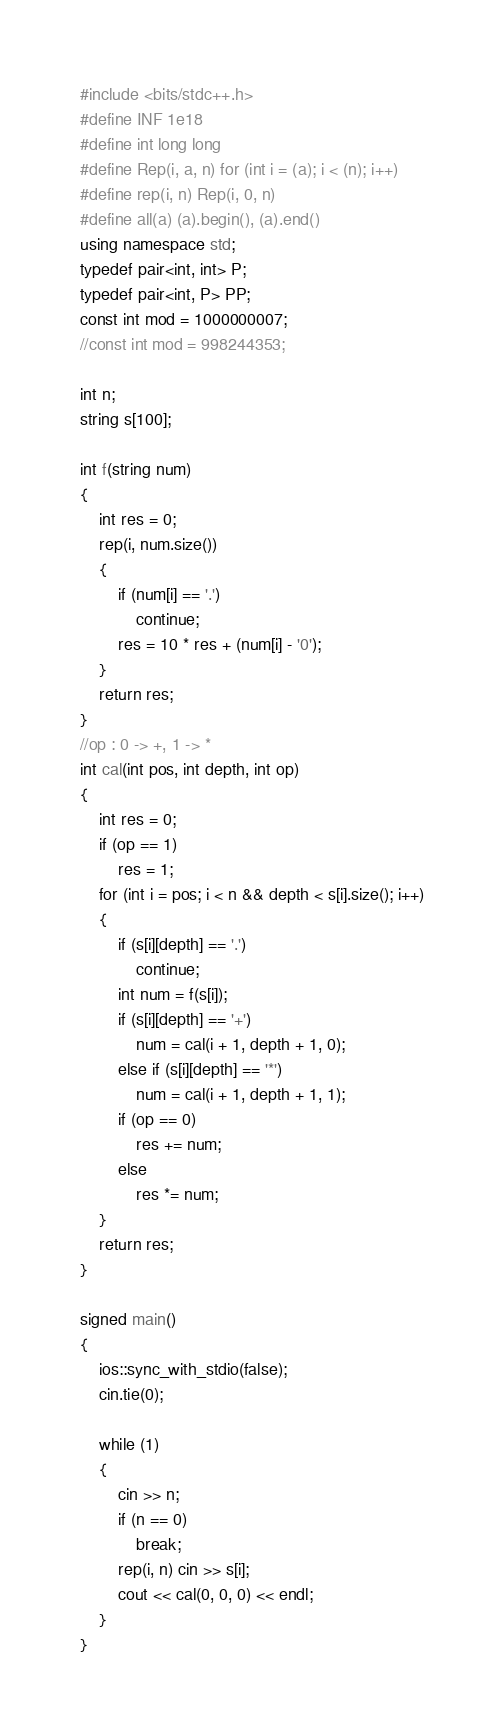Convert code to text. <code><loc_0><loc_0><loc_500><loc_500><_C++_>#include <bits/stdc++.h>
#define INF 1e18
#define int long long
#define Rep(i, a, n) for (int i = (a); i < (n); i++)
#define rep(i, n) Rep(i, 0, n)
#define all(a) (a).begin(), (a).end()
using namespace std;
typedef pair<int, int> P;
typedef pair<int, P> PP;
const int mod = 1000000007;
//const int mod = 998244353;

int n;
string s[100];

int f(string num)
{
    int res = 0;
    rep(i, num.size())
    {
        if (num[i] == '.')
            continue;
        res = 10 * res + (num[i] - '0');
    }
    return res;
}
//op : 0 -> +, 1 -> *
int cal(int pos, int depth, int op)
{
    int res = 0;
    if (op == 1)
        res = 1;
    for (int i = pos; i < n && depth < s[i].size(); i++)
    {
        if (s[i][depth] == '.')
            continue;
        int num = f(s[i]);
        if (s[i][depth] == '+')
            num = cal(i + 1, depth + 1, 0);
        else if (s[i][depth] == '*')
            num = cal(i + 1, depth + 1, 1);
        if (op == 0)
            res += num;
        else
            res *= num;
    }
    return res;
}

signed main()
{
    ios::sync_with_stdio(false);
    cin.tie(0);

    while (1)
    {
        cin >> n;
        if (n == 0)
            break;
        rep(i, n) cin >> s[i];
        cout << cal(0, 0, 0) << endl;
    }
}

</code> 